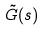<formula> <loc_0><loc_0><loc_500><loc_500>\tilde { G } ( s )</formula> 